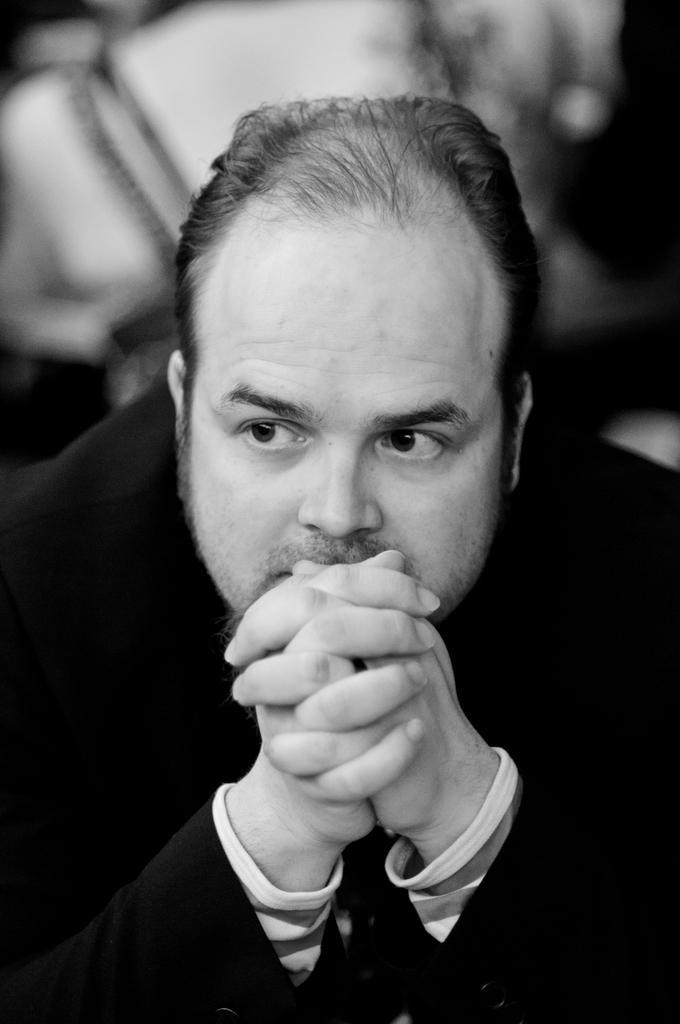Please provide a concise description of this image. In this picture there is a black and white photograph of a man wearing a black coat, sitting and holding the hands, giving a pose into the camera. Behind there is a blur background. 